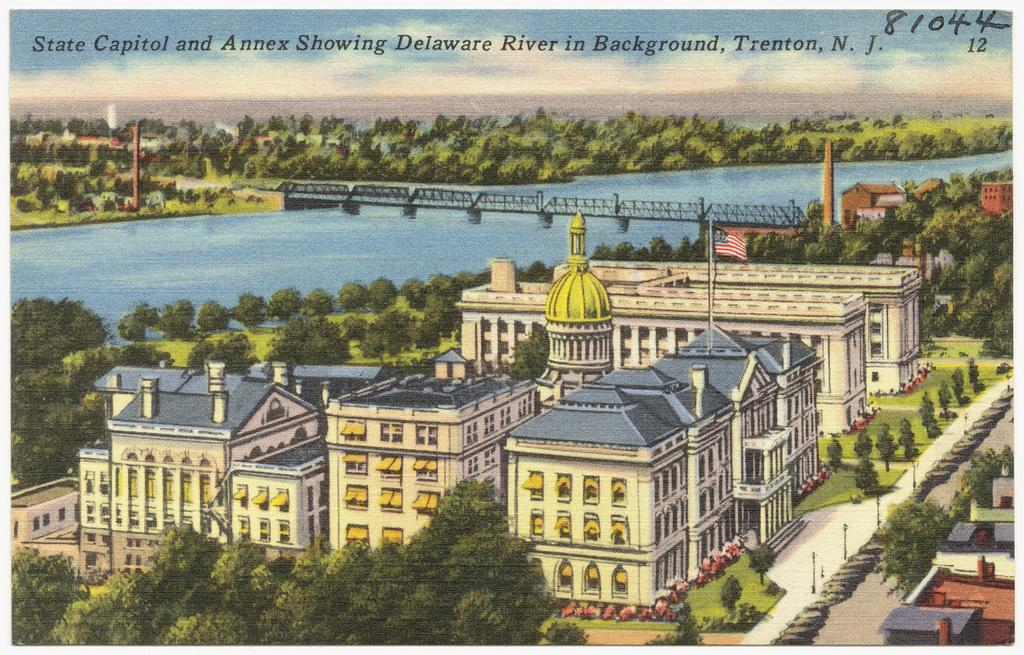<image>
Relay a brief, clear account of the picture shown. A postcard has the number 81044 written in the corner. 